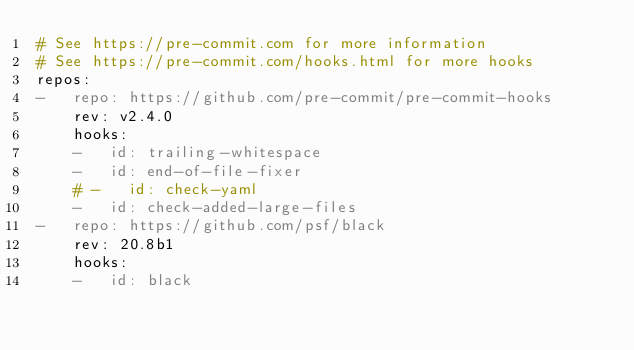<code> <loc_0><loc_0><loc_500><loc_500><_YAML_># See https://pre-commit.com for more information
# See https://pre-commit.com/hooks.html for more hooks
repos:
-   repo: https://github.com/pre-commit/pre-commit-hooks
    rev: v2.4.0
    hooks:
    -   id: trailing-whitespace
    -   id: end-of-file-fixer
    # -   id: check-yaml
    -   id: check-added-large-files
-   repo: https://github.com/psf/black
    rev: 20.8b1
    hooks:
    -   id: black
</code> 